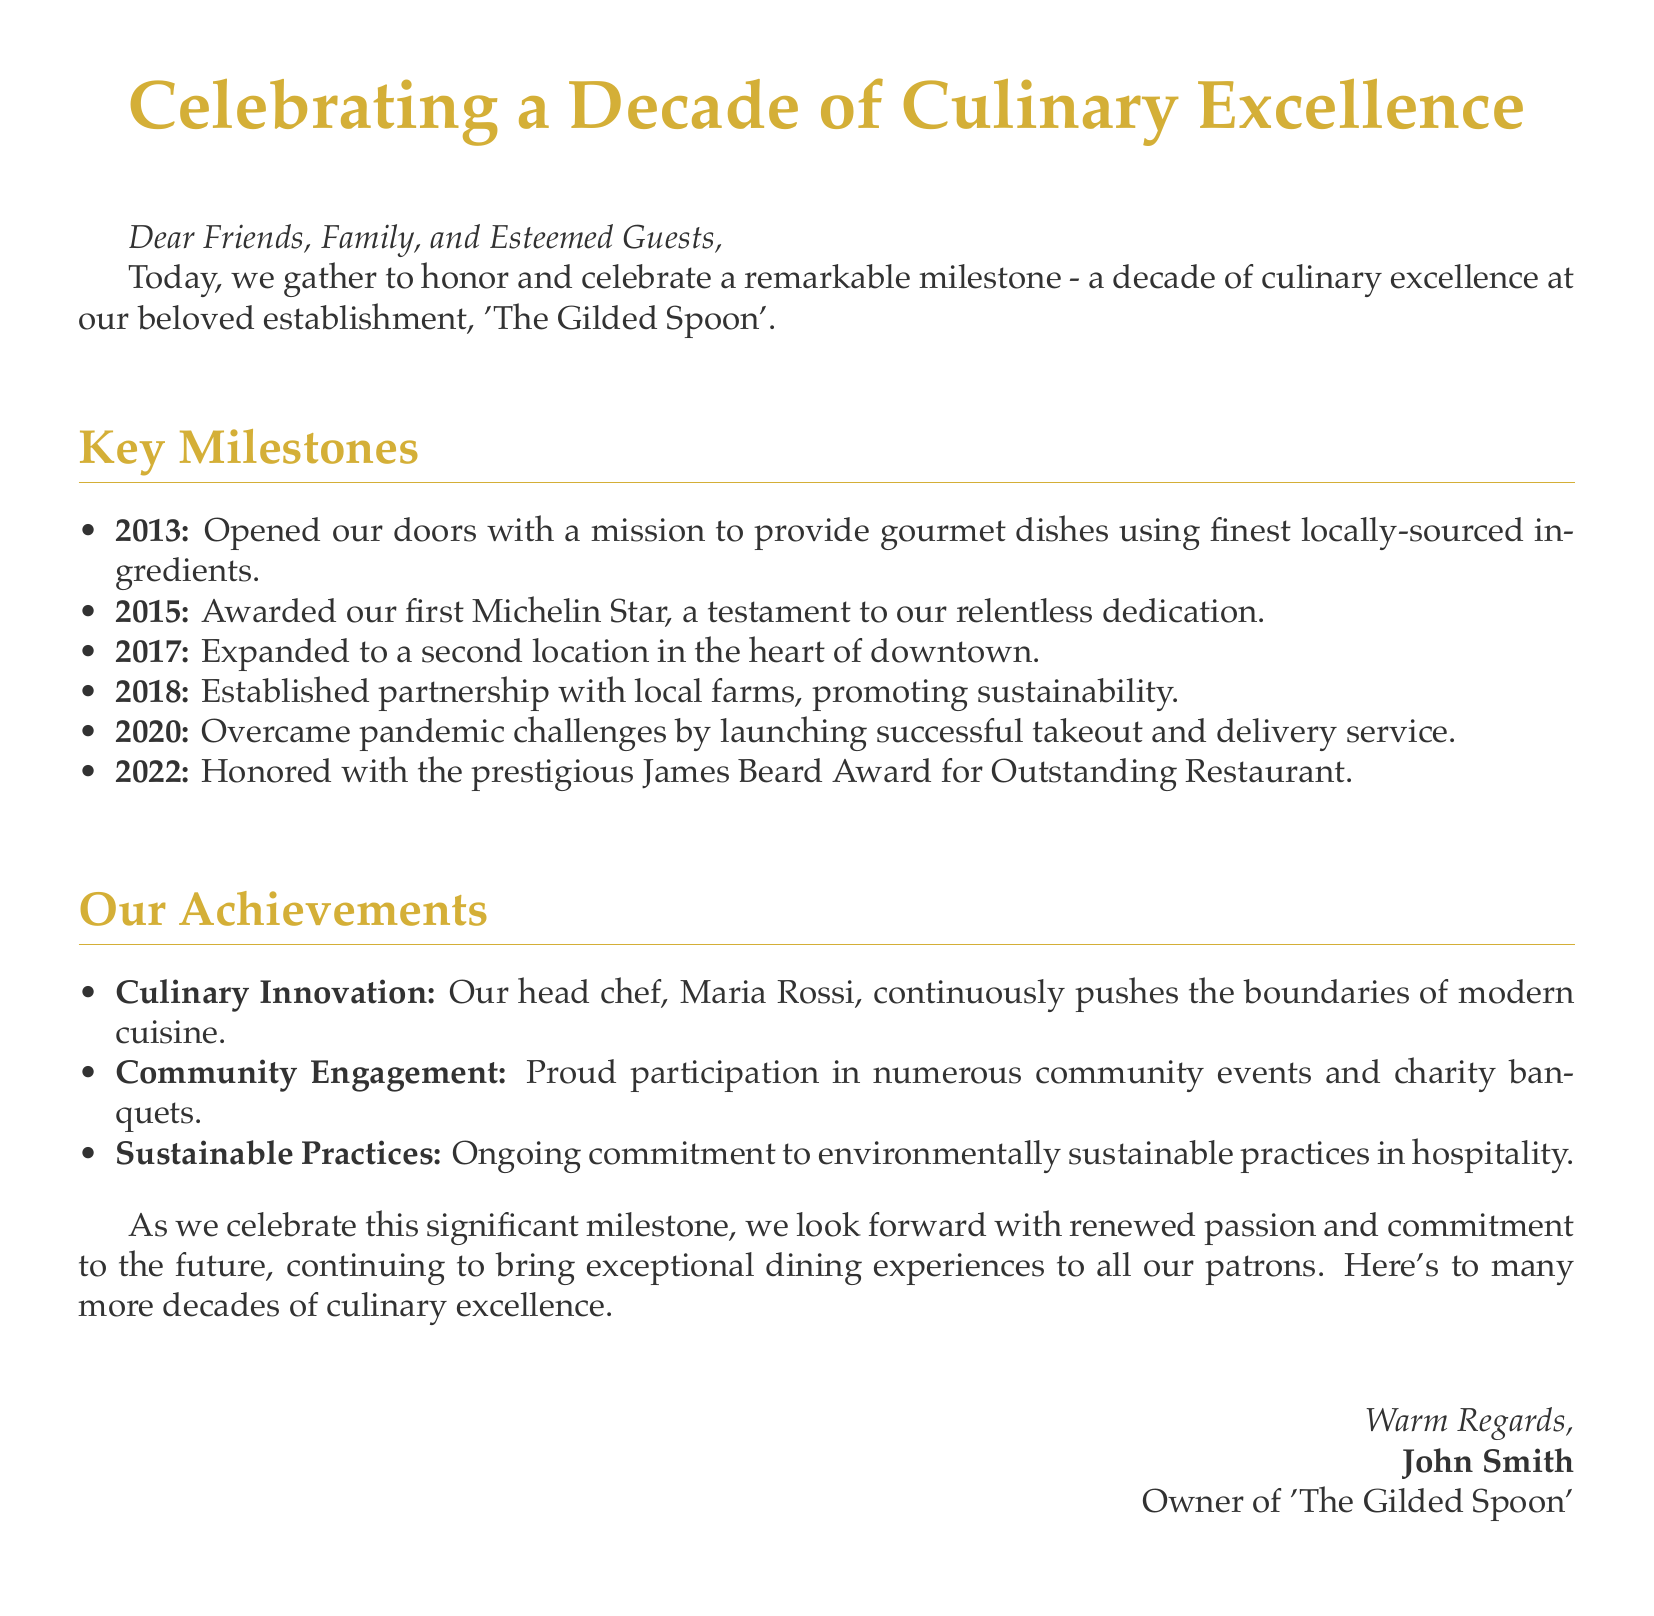What year was 'The Gilded Spoon' opened? The document states that the restaurant opened its doors in 2013.
Answer: 2013 How many Michelin Stars has 'The Gilded Spoon' received? The restaurant was awarded its first Michelin Star in 2015, hence it has received one Michelin Star.
Answer: One What significant event occurred in 2020? The document mentions that the restaurant overcame pandemic challenges by launching a successful takeout and delivery service in 2020.
Answer: Successful takeout Who is the head chef at 'The Gilded Spoon'? The document specifies that the head chef is Maria Rossi.
Answer: Maria Rossi What award did 'The Gilded Spoon' win in 2022? The restaurant was honored with the prestigious James Beard Award for Outstanding Restaurant in 2022.
Answer: James Beard Award What is the mission of 'The Gilded Spoon'? The mission, as described in the document, is to provide gourmet dishes using the finest locally-sourced ingredients.
Answer: Gourmet dishes using finest locally-sourced ingredients How many locations does 'The Gilded Spoon' have? The document indicates that the restaurant expanded to a second location in 2017, suggesting that it has two locations.
Answer: Two locations What sustainable practice did 'The Gilded Spoon' establish in 2018? The restaurant established a partnership with local farms to promote sustainability in 2018.
Answer: Partnership with local farms What does the document express about the restaurant's future? The eulogy conveys a renewed passion and commitment to continue exceptional dining experiences.
Answer: Renewed passion and commitment 